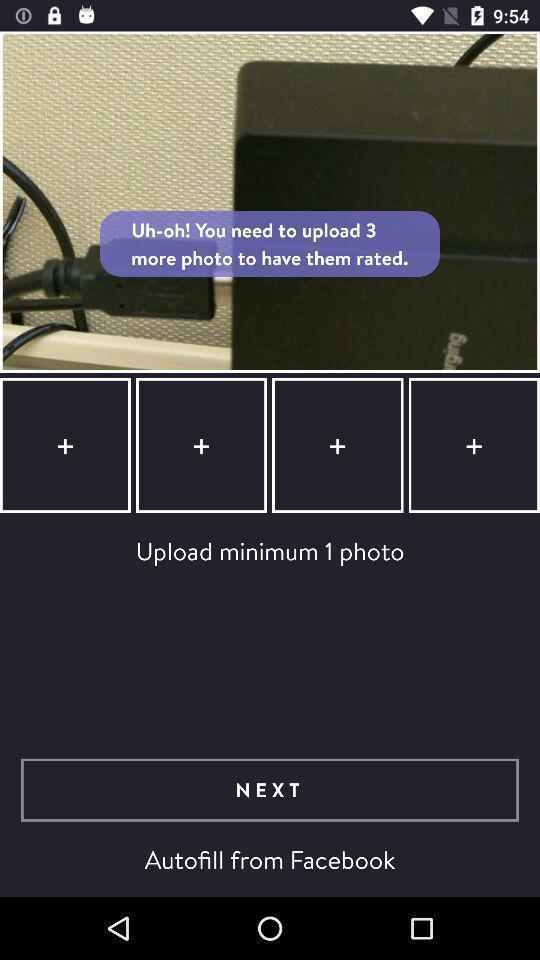Tell me what you see in this picture. Uploading photo in dating app to rate. 